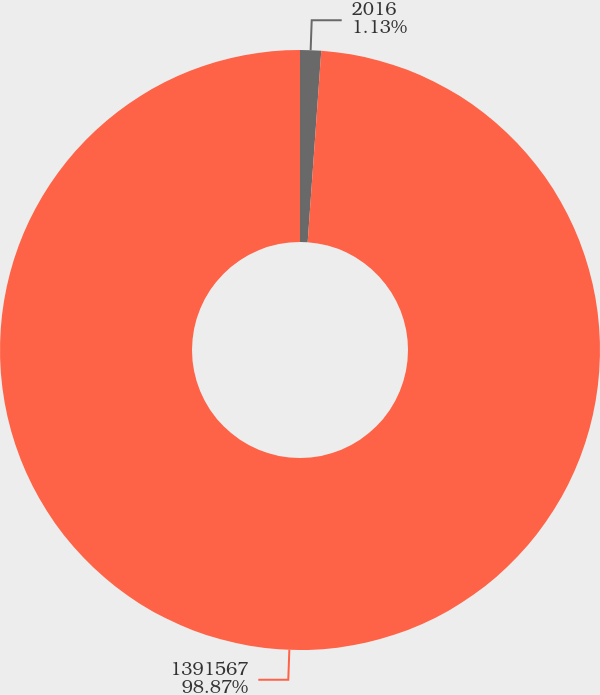Convert chart. <chart><loc_0><loc_0><loc_500><loc_500><pie_chart><fcel>2016<fcel>1391567<nl><fcel>1.13%<fcel>98.87%<nl></chart> 